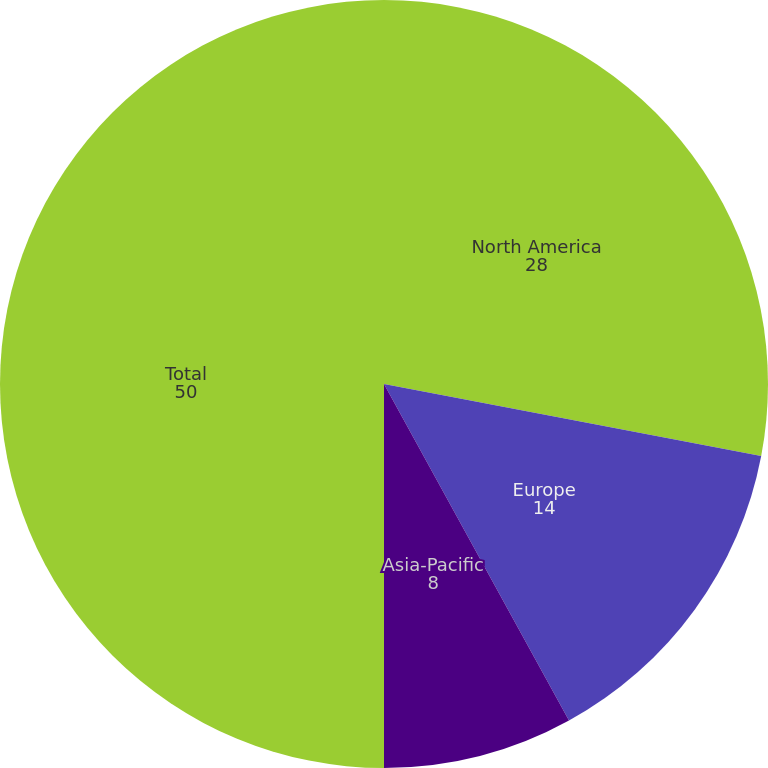Convert chart. <chart><loc_0><loc_0><loc_500><loc_500><pie_chart><fcel>North America<fcel>Europe<fcel>Asia-Pacific<fcel>Total<nl><fcel>28.0%<fcel>14.0%<fcel>8.0%<fcel>50.0%<nl></chart> 